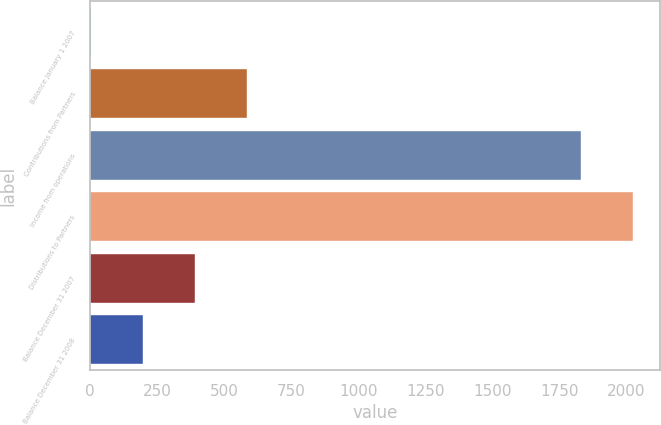Convert chart. <chart><loc_0><loc_0><loc_500><loc_500><bar_chart><fcel>Balance January 1 2007<fcel>Contributions from Partners<fcel>Income from operations<fcel>Distributions to Partners<fcel>Balance December 31 2007<fcel>Balance December 31 2008<nl><fcel>2<fcel>584.6<fcel>1831<fcel>2025.2<fcel>390.4<fcel>196.2<nl></chart> 